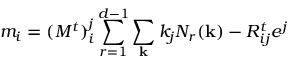Convert formula to latex. <formula><loc_0><loc_0><loc_500><loc_500>m _ { i } = ( M ^ { t } ) _ { i } ^ { j } \sum _ { r = 1 } ^ { d - 1 } \sum _ { k } k _ { j } N _ { r } ( { k } ) - R _ { i j } ^ { t } e ^ { j }</formula> 